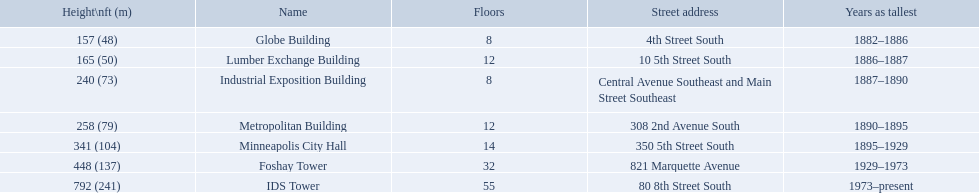What are the tallest buildings in minneapolis? Globe Building, Lumber Exchange Building, Industrial Exposition Building, Metropolitan Building, Minneapolis City Hall, Foshay Tower, IDS Tower. What is the height of the metropolitan building? 258 (79). What is the height of the lumber exchange building? 165 (50). Of those two which is taller? Metropolitan Building. What are the heights of the buildings? 157 (48), 165 (50), 240 (73), 258 (79), 341 (104), 448 (137), 792 (241). What building is 240 ft tall? Industrial Exposition Building. 